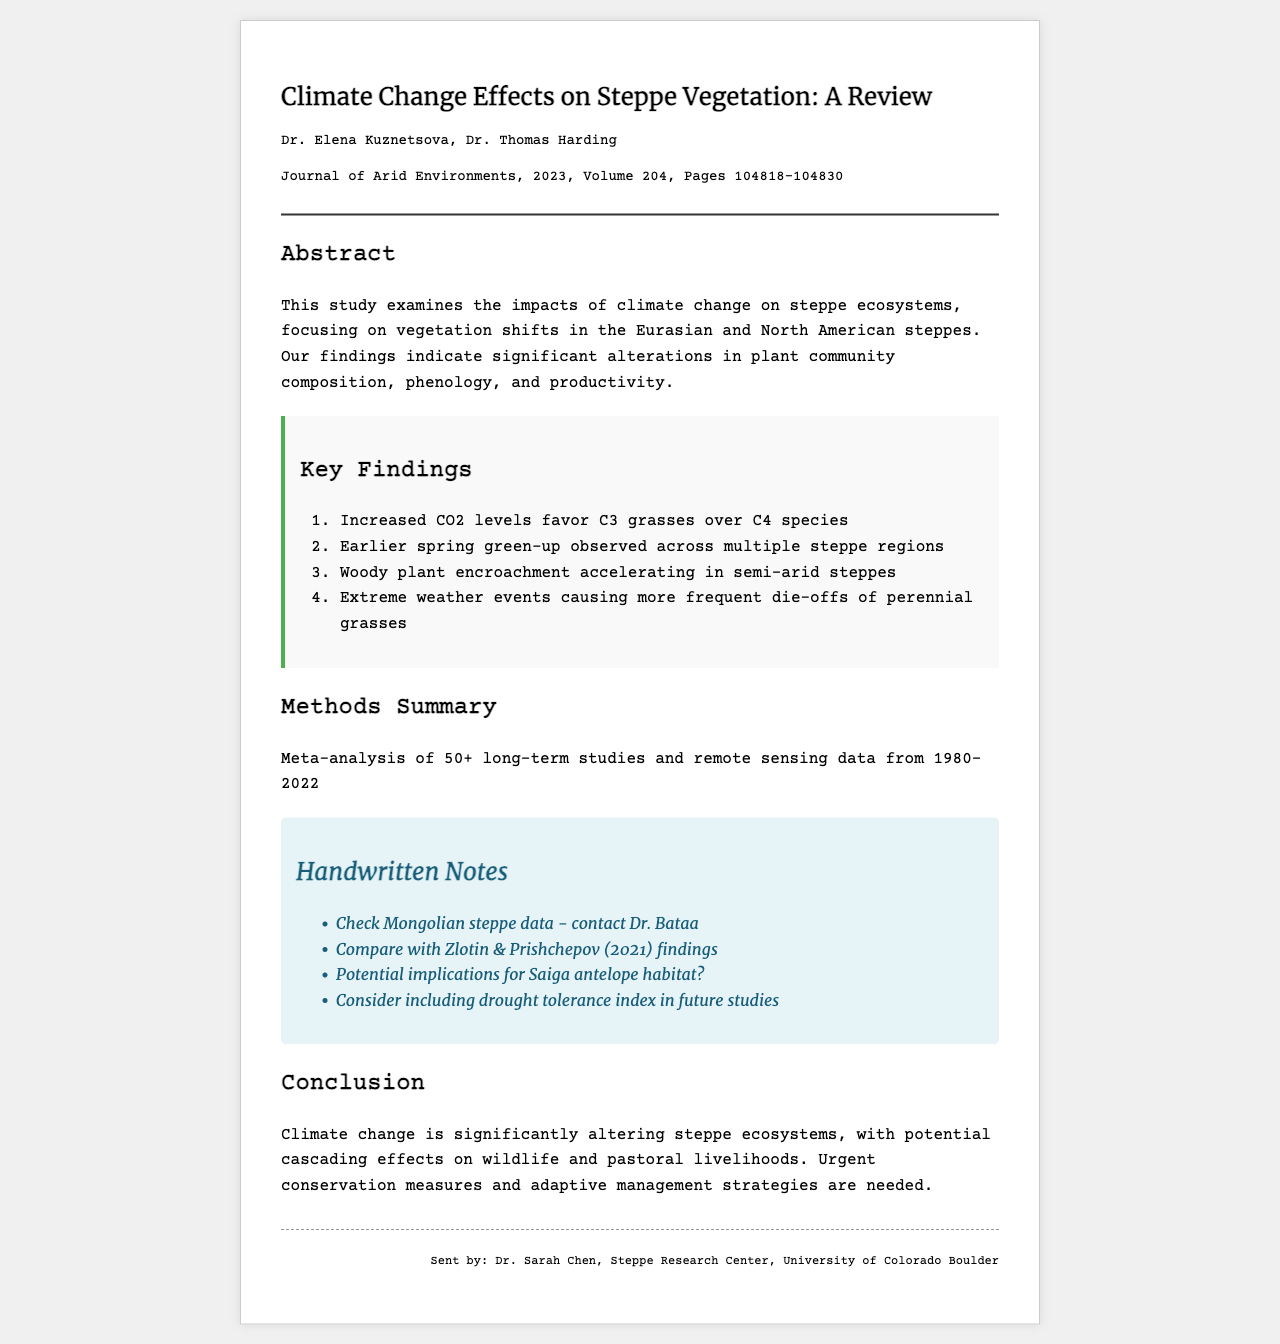What is the title of the paper? The title of the paper is displayed prominently at the top of the document.
Answer: Climate Change Effects on Steppe Vegetation: A Review Who are the authors of the study? The authors' names are listed below the title of the paper.
Answer: Dr. Elena Kuznetsova, Dr. Thomas Harding In which journal was the paper published? The journal name is included in the journal info section.
Answer: Journal of Arid Environments What is the volume number of the journal? The volume number is provided in the citation of the journal information.
Answer: 204 What is a key finding related to plant species? This question addresses the key findings section detailing specific impacts on plant species.
Answer: Increased CO2 levels favor C3 grasses over C4 species What does the conclusion emphasize regarding climate change? This question requires understanding the broader implications discussed in the conclusion.
Answer: Urgent conservation measures and adaptive management strategies are needed How many long-term studies were analyzed? The methods summary outlines the number of studies used for the analysis.
Answer: 50+ What is a handwritten note about future studies? This question looks for specific commentary included in the handwritten notes section.
Answer: Consider including drought tolerance index in future studies What year range does the remote sensing data cover? The methods section specifies the years covered by remote sensing data analysis.
Answer: 1980-2022 What does the paper suggest about the Saiga antelope? The handwritten notes indicate potential implications for a specific species.
Answer: Potential implications for Saiga antelope habitat? 